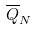<formula> <loc_0><loc_0><loc_500><loc_500>\overline { Q } _ { N }</formula> 